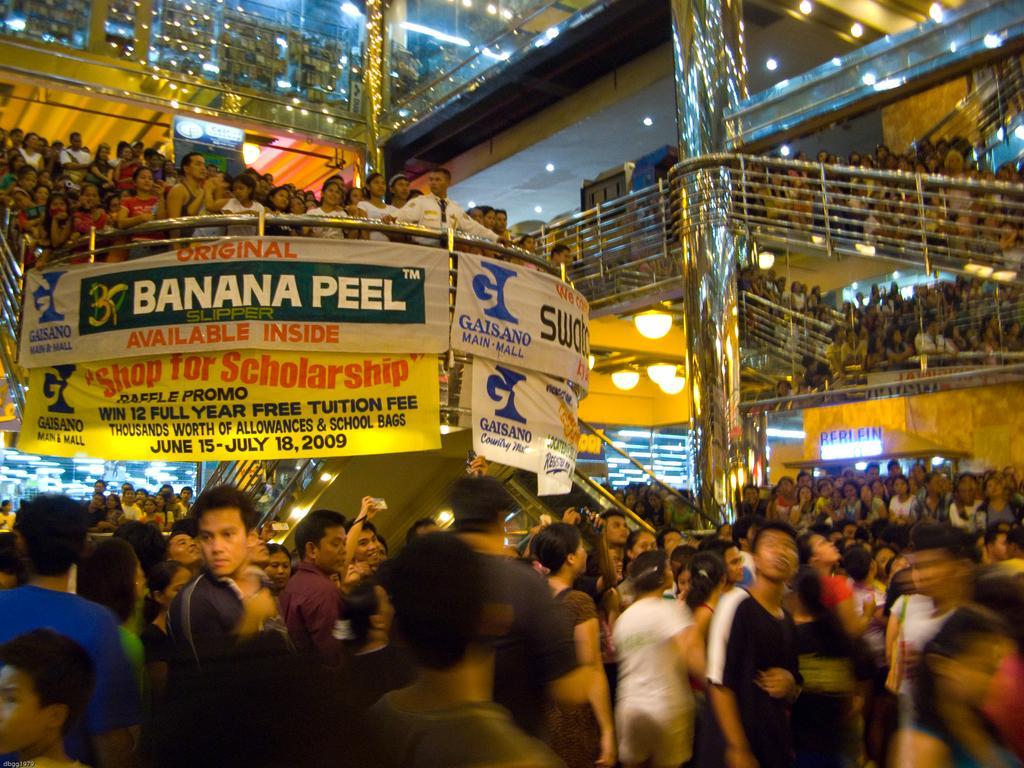Describe this image in one or two sentences. In this image in the center there are group of persons standing and there are banners with some text written on it which is hanging on the wall and on the top there are persons and there are lights on the roof. 